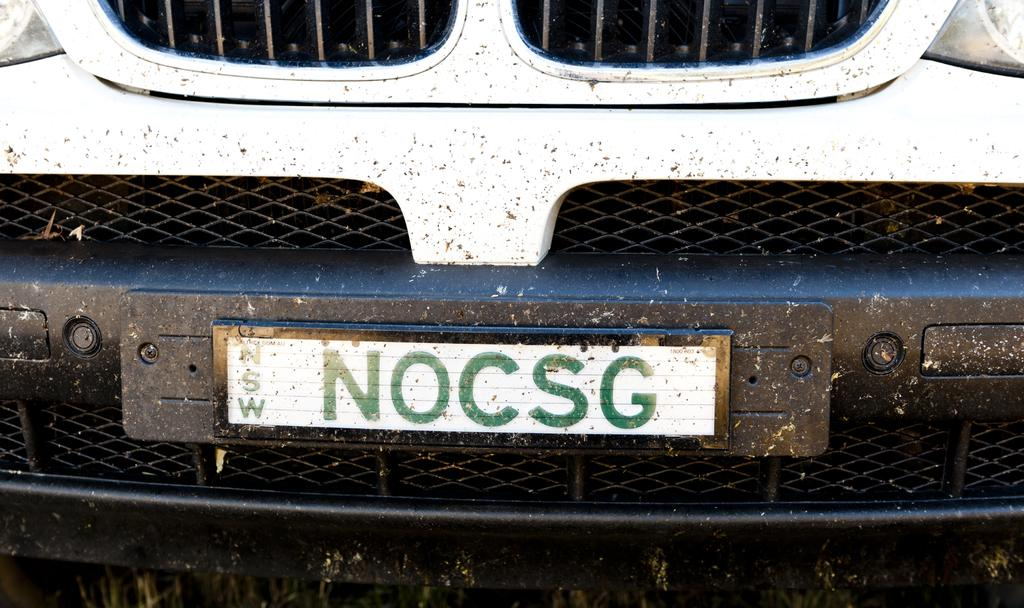<image>
Render a clear and concise summary of the photo. The bumper and grill of a white vehicle with tag NOCSG is splattered with mud. 